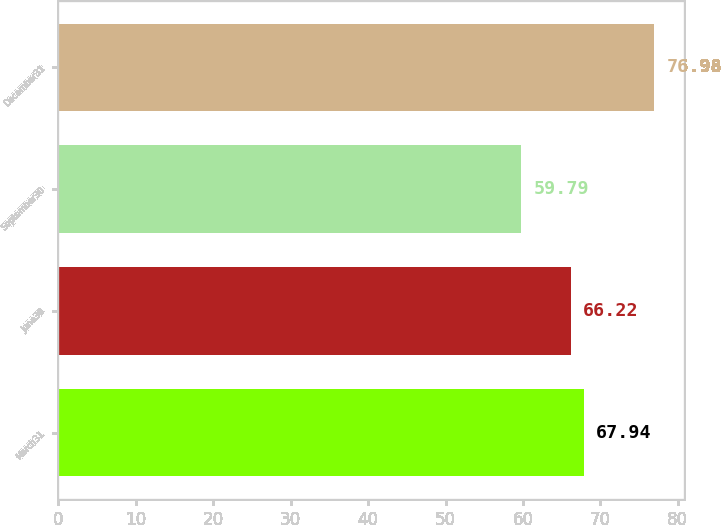<chart> <loc_0><loc_0><loc_500><loc_500><bar_chart><fcel>March31<fcel>June30<fcel>September30<fcel>December31<nl><fcel>67.94<fcel>66.22<fcel>59.79<fcel>76.98<nl></chart> 